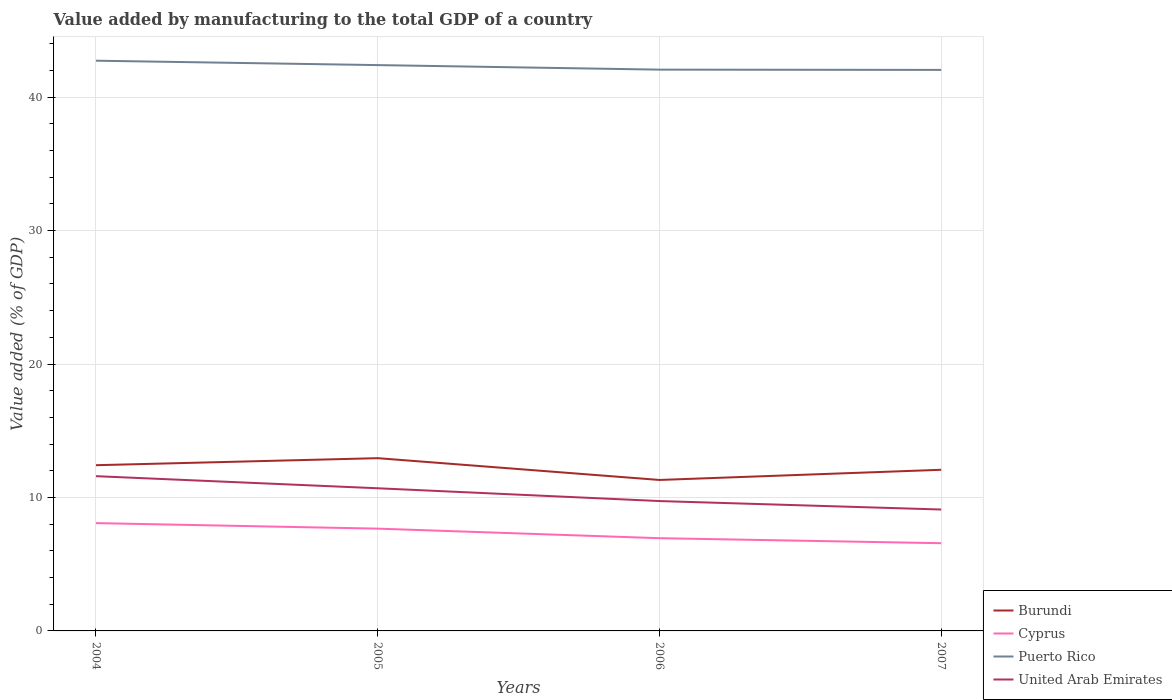Does the line corresponding to United Arab Emirates intersect with the line corresponding to Burundi?
Provide a short and direct response. No. Across all years, what is the maximum value added by manufacturing to the total GDP in Burundi?
Make the answer very short. 11.31. In which year was the value added by manufacturing to the total GDP in United Arab Emirates maximum?
Give a very brief answer. 2007. What is the total value added by manufacturing to the total GDP in United Arab Emirates in the graph?
Provide a succinct answer. 0.63. What is the difference between the highest and the second highest value added by manufacturing to the total GDP in Burundi?
Your response must be concise. 1.63. What is the difference between the highest and the lowest value added by manufacturing to the total GDP in Puerto Rico?
Keep it short and to the point. 2. How many lines are there?
Your response must be concise. 4. How many years are there in the graph?
Provide a succinct answer. 4. Are the values on the major ticks of Y-axis written in scientific E-notation?
Keep it short and to the point. No. Does the graph contain any zero values?
Offer a terse response. No. What is the title of the graph?
Give a very brief answer. Value added by manufacturing to the total GDP of a country. What is the label or title of the X-axis?
Your response must be concise. Years. What is the label or title of the Y-axis?
Offer a terse response. Value added (% of GDP). What is the Value added (% of GDP) in Burundi in 2004?
Your answer should be compact. 12.42. What is the Value added (% of GDP) in Cyprus in 2004?
Your answer should be very brief. 8.08. What is the Value added (% of GDP) in Puerto Rico in 2004?
Provide a short and direct response. 42.73. What is the Value added (% of GDP) of United Arab Emirates in 2004?
Your answer should be compact. 11.6. What is the Value added (% of GDP) of Burundi in 2005?
Keep it short and to the point. 12.95. What is the Value added (% of GDP) in Cyprus in 2005?
Your response must be concise. 7.66. What is the Value added (% of GDP) in Puerto Rico in 2005?
Keep it short and to the point. 42.4. What is the Value added (% of GDP) of United Arab Emirates in 2005?
Ensure brevity in your answer.  10.69. What is the Value added (% of GDP) in Burundi in 2006?
Your answer should be very brief. 11.31. What is the Value added (% of GDP) of Cyprus in 2006?
Provide a short and direct response. 6.95. What is the Value added (% of GDP) in Puerto Rico in 2006?
Your answer should be very brief. 42.06. What is the Value added (% of GDP) of United Arab Emirates in 2006?
Offer a terse response. 9.73. What is the Value added (% of GDP) in Burundi in 2007?
Provide a succinct answer. 12.07. What is the Value added (% of GDP) of Cyprus in 2007?
Your answer should be compact. 6.57. What is the Value added (% of GDP) in Puerto Rico in 2007?
Make the answer very short. 42.04. What is the Value added (% of GDP) of United Arab Emirates in 2007?
Provide a succinct answer. 9.1. Across all years, what is the maximum Value added (% of GDP) in Burundi?
Your response must be concise. 12.95. Across all years, what is the maximum Value added (% of GDP) in Cyprus?
Offer a terse response. 8.08. Across all years, what is the maximum Value added (% of GDP) in Puerto Rico?
Offer a very short reply. 42.73. Across all years, what is the maximum Value added (% of GDP) of United Arab Emirates?
Make the answer very short. 11.6. Across all years, what is the minimum Value added (% of GDP) of Burundi?
Provide a succinct answer. 11.31. Across all years, what is the minimum Value added (% of GDP) of Cyprus?
Ensure brevity in your answer.  6.57. Across all years, what is the minimum Value added (% of GDP) in Puerto Rico?
Your answer should be very brief. 42.04. Across all years, what is the minimum Value added (% of GDP) of United Arab Emirates?
Provide a short and direct response. 9.1. What is the total Value added (% of GDP) in Burundi in the graph?
Give a very brief answer. 48.75. What is the total Value added (% of GDP) of Cyprus in the graph?
Your answer should be compact. 29.27. What is the total Value added (% of GDP) in Puerto Rico in the graph?
Keep it short and to the point. 169.23. What is the total Value added (% of GDP) in United Arab Emirates in the graph?
Your answer should be very brief. 41.12. What is the difference between the Value added (% of GDP) of Burundi in 2004 and that in 2005?
Offer a very short reply. -0.53. What is the difference between the Value added (% of GDP) of Cyprus in 2004 and that in 2005?
Make the answer very short. 0.42. What is the difference between the Value added (% of GDP) in Puerto Rico in 2004 and that in 2005?
Provide a succinct answer. 0.33. What is the difference between the Value added (% of GDP) of United Arab Emirates in 2004 and that in 2005?
Make the answer very short. 0.91. What is the difference between the Value added (% of GDP) in Burundi in 2004 and that in 2006?
Your response must be concise. 1.11. What is the difference between the Value added (% of GDP) of Cyprus in 2004 and that in 2006?
Your answer should be very brief. 1.13. What is the difference between the Value added (% of GDP) of Puerto Rico in 2004 and that in 2006?
Offer a very short reply. 0.67. What is the difference between the Value added (% of GDP) of United Arab Emirates in 2004 and that in 2006?
Your response must be concise. 1.86. What is the difference between the Value added (% of GDP) in Burundi in 2004 and that in 2007?
Offer a very short reply. 0.34. What is the difference between the Value added (% of GDP) of Cyprus in 2004 and that in 2007?
Offer a very short reply. 1.51. What is the difference between the Value added (% of GDP) of Puerto Rico in 2004 and that in 2007?
Offer a terse response. 0.69. What is the difference between the Value added (% of GDP) in United Arab Emirates in 2004 and that in 2007?
Keep it short and to the point. 2.5. What is the difference between the Value added (% of GDP) in Burundi in 2005 and that in 2006?
Offer a terse response. 1.63. What is the difference between the Value added (% of GDP) in Cyprus in 2005 and that in 2006?
Give a very brief answer. 0.71. What is the difference between the Value added (% of GDP) in Puerto Rico in 2005 and that in 2006?
Your answer should be very brief. 0.34. What is the difference between the Value added (% of GDP) in United Arab Emirates in 2005 and that in 2006?
Offer a terse response. 0.96. What is the difference between the Value added (% of GDP) of Burundi in 2005 and that in 2007?
Keep it short and to the point. 0.87. What is the difference between the Value added (% of GDP) in Cyprus in 2005 and that in 2007?
Provide a short and direct response. 1.09. What is the difference between the Value added (% of GDP) in Puerto Rico in 2005 and that in 2007?
Offer a very short reply. 0.36. What is the difference between the Value added (% of GDP) in United Arab Emirates in 2005 and that in 2007?
Your response must be concise. 1.59. What is the difference between the Value added (% of GDP) in Burundi in 2006 and that in 2007?
Keep it short and to the point. -0.76. What is the difference between the Value added (% of GDP) of Cyprus in 2006 and that in 2007?
Offer a terse response. 0.38. What is the difference between the Value added (% of GDP) in Puerto Rico in 2006 and that in 2007?
Keep it short and to the point. 0.02. What is the difference between the Value added (% of GDP) of United Arab Emirates in 2006 and that in 2007?
Your answer should be very brief. 0.63. What is the difference between the Value added (% of GDP) of Burundi in 2004 and the Value added (% of GDP) of Cyprus in 2005?
Give a very brief answer. 4.75. What is the difference between the Value added (% of GDP) in Burundi in 2004 and the Value added (% of GDP) in Puerto Rico in 2005?
Provide a short and direct response. -29.98. What is the difference between the Value added (% of GDP) in Burundi in 2004 and the Value added (% of GDP) in United Arab Emirates in 2005?
Your answer should be very brief. 1.73. What is the difference between the Value added (% of GDP) of Cyprus in 2004 and the Value added (% of GDP) of Puerto Rico in 2005?
Provide a short and direct response. -34.32. What is the difference between the Value added (% of GDP) in Cyprus in 2004 and the Value added (% of GDP) in United Arab Emirates in 2005?
Give a very brief answer. -2.61. What is the difference between the Value added (% of GDP) in Puerto Rico in 2004 and the Value added (% of GDP) in United Arab Emirates in 2005?
Keep it short and to the point. 32.04. What is the difference between the Value added (% of GDP) of Burundi in 2004 and the Value added (% of GDP) of Cyprus in 2006?
Provide a short and direct response. 5.47. What is the difference between the Value added (% of GDP) in Burundi in 2004 and the Value added (% of GDP) in Puerto Rico in 2006?
Your answer should be compact. -29.64. What is the difference between the Value added (% of GDP) of Burundi in 2004 and the Value added (% of GDP) of United Arab Emirates in 2006?
Offer a terse response. 2.69. What is the difference between the Value added (% of GDP) of Cyprus in 2004 and the Value added (% of GDP) of Puerto Rico in 2006?
Your answer should be compact. -33.98. What is the difference between the Value added (% of GDP) of Cyprus in 2004 and the Value added (% of GDP) of United Arab Emirates in 2006?
Provide a succinct answer. -1.65. What is the difference between the Value added (% of GDP) in Puerto Rico in 2004 and the Value added (% of GDP) in United Arab Emirates in 2006?
Make the answer very short. 33. What is the difference between the Value added (% of GDP) in Burundi in 2004 and the Value added (% of GDP) in Cyprus in 2007?
Offer a very short reply. 5.84. What is the difference between the Value added (% of GDP) of Burundi in 2004 and the Value added (% of GDP) of Puerto Rico in 2007?
Offer a very short reply. -29.62. What is the difference between the Value added (% of GDP) in Burundi in 2004 and the Value added (% of GDP) in United Arab Emirates in 2007?
Your answer should be compact. 3.32. What is the difference between the Value added (% of GDP) in Cyprus in 2004 and the Value added (% of GDP) in Puerto Rico in 2007?
Give a very brief answer. -33.96. What is the difference between the Value added (% of GDP) in Cyprus in 2004 and the Value added (% of GDP) in United Arab Emirates in 2007?
Your answer should be compact. -1.02. What is the difference between the Value added (% of GDP) of Puerto Rico in 2004 and the Value added (% of GDP) of United Arab Emirates in 2007?
Keep it short and to the point. 33.63. What is the difference between the Value added (% of GDP) in Burundi in 2005 and the Value added (% of GDP) in Cyprus in 2006?
Your answer should be very brief. 6. What is the difference between the Value added (% of GDP) in Burundi in 2005 and the Value added (% of GDP) in Puerto Rico in 2006?
Your answer should be very brief. -29.12. What is the difference between the Value added (% of GDP) in Burundi in 2005 and the Value added (% of GDP) in United Arab Emirates in 2006?
Offer a terse response. 3.21. What is the difference between the Value added (% of GDP) of Cyprus in 2005 and the Value added (% of GDP) of Puerto Rico in 2006?
Your response must be concise. -34.4. What is the difference between the Value added (% of GDP) of Cyprus in 2005 and the Value added (% of GDP) of United Arab Emirates in 2006?
Ensure brevity in your answer.  -2.07. What is the difference between the Value added (% of GDP) in Puerto Rico in 2005 and the Value added (% of GDP) in United Arab Emirates in 2006?
Give a very brief answer. 32.67. What is the difference between the Value added (% of GDP) of Burundi in 2005 and the Value added (% of GDP) of Cyprus in 2007?
Your response must be concise. 6.37. What is the difference between the Value added (% of GDP) in Burundi in 2005 and the Value added (% of GDP) in Puerto Rico in 2007?
Your answer should be compact. -29.1. What is the difference between the Value added (% of GDP) of Burundi in 2005 and the Value added (% of GDP) of United Arab Emirates in 2007?
Offer a terse response. 3.85. What is the difference between the Value added (% of GDP) in Cyprus in 2005 and the Value added (% of GDP) in Puerto Rico in 2007?
Ensure brevity in your answer.  -34.38. What is the difference between the Value added (% of GDP) in Cyprus in 2005 and the Value added (% of GDP) in United Arab Emirates in 2007?
Keep it short and to the point. -1.43. What is the difference between the Value added (% of GDP) in Puerto Rico in 2005 and the Value added (% of GDP) in United Arab Emirates in 2007?
Your response must be concise. 33.3. What is the difference between the Value added (% of GDP) of Burundi in 2006 and the Value added (% of GDP) of Cyprus in 2007?
Give a very brief answer. 4.74. What is the difference between the Value added (% of GDP) in Burundi in 2006 and the Value added (% of GDP) in Puerto Rico in 2007?
Offer a terse response. -30.73. What is the difference between the Value added (% of GDP) of Burundi in 2006 and the Value added (% of GDP) of United Arab Emirates in 2007?
Offer a terse response. 2.21. What is the difference between the Value added (% of GDP) in Cyprus in 2006 and the Value added (% of GDP) in Puerto Rico in 2007?
Provide a short and direct response. -35.09. What is the difference between the Value added (% of GDP) in Cyprus in 2006 and the Value added (% of GDP) in United Arab Emirates in 2007?
Ensure brevity in your answer.  -2.15. What is the difference between the Value added (% of GDP) in Puerto Rico in 2006 and the Value added (% of GDP) in United Arab Emirates in 2007?
Offer a terse response. 32.96. What is the average Value added (% of GDP) of Burundi per year?
Give a very brief answer. 12.19. What is the average Value added (% of GDP) of Cyprus per year?
Ensure brevity in your answer.  7.32. What is the average Value added (% of GDP) of Puerto Rico per year?
Your response must be concise. 42.31. What is the average Value added (% of GDP) of United Arab Emirates per year?
Provide a short and direct response. 10.28. In the year 2004, what is the difference between the Value added (% of GDP) in Burundi and Value added (% of GDP) in Cyprus?
Provide a short and direct response. 4.34. In the year 2004, what is the difference between the Value added (% of GDP) of Burundi and Value added (% of GDP) of Puerto Rico?
Give a very brief answer. -30.31. In the year 2004, what is the difference between the Value added (% of GDP) of Burundi and Value added (% of GDP) of United Arab Emirates?
Your answer should be compact. 0.82. In the year 2004, what is the difference between the Value added (% of GDP) of Cyprus and Value added (% of GDP) of Puerto Rico?
Provide a short and direct response. -34.65. In the year 2004, what is the difference between the Value added (% of GDP) in Cyprus and Value added (% of GDP) in United Arab Emirates?
Ensure brevity in your answer.  -3.52. In the year 2004, what is the difference between the Value added (% of GDP) of Puerto Rico and Value added (% of GDP) of United Arab Emirates?
Give a very brief answer. 31.13. In the year 2005, what is the difference between the Value added (% of GDP) of Burundi and Value added (% of GDP) of Cyprus?
Offer a very short reply. 5.28. In the year 2005, what is the difference between the Value added (% of GDP) of Burundi and Value added (% of GDP) of Puerto Rico?
Offer a very short reply. -29.46. In the year 2005, what is the difference between the Value added (% of GDP) of Burundi and Value added (% of GDP) of United Arab Emirates?
Ensure brevity in your answer.  2.26. In the year 2005, what is the difference between the Value added (% of GDP) of Cyprus and Value added (% of GDP) of Puerto Rico?
Make the answer very short. -34.74. In the year 2005, what is the difference between the Value added (% of GDP) of Cyprus and Value added (% of GDP) of United Arab Emirates?
Offer a very short reply. -3.03. In the year 2005, what is the difference between the Value added (% of GDP) of Puerto Rico and Value added (% of GDP) of United Arab Emirates?
Offer a very short reply. 31.71. In the year 2006, what is the difference between the Value added (% of GDP) in Burundi and Value added (% of GDP) in Cyprus?
Ensure brevity in your answer.  4.36. In the year 2006, what is the difference between the Value added (% of GDP) in Burundi and Value added (% of GDP) in Puerto Rico?
Ensure brevity in your answer.  -30.75. In the year 2006, what is the difference between the Value added (% of GDP) in Burundi and Value added (% of GDP) in United Arab Emirates?
Make the answer very short. 1.58. In the year 2006, what is the difference between the Value added (% of GDP) in Cyprus and Value added (% of GDP) in Puerto Rico?
Give a very brief answer. -35.11. In the year 2006, what is the difference between the Value added (% of GDP) of Cyprus and Value added (% of GDP) of United Arab Emirates?
Ensure brevity in your answer.  -2.78. In the year 2006, what is the difference between the Value added (% of GDP) in Puerto Rico and Value added (% of GDP) in United Arab Emirates?
Offer a terse response. 32.33. In the year 2007, what is the difference between the Value added (% of GDP) of Burundi and Value added (% of GDP) of Cyprus?
Your answer should be compact. 5.5. In the year 2007, what is the difference between the Value added (% of GDP) in Burundi and Value added (% of GDP) in Puerto Rico?
Your answer should be very brief. -29.97. In the year 2007, what is the difference between the Value added (% of GDP) in Burundi and Value added (% of GDP) in United Arab Emirates?
Offer a terse response. 2.98. In the year 2007, what is the difference between the Value added (% of GDP) in Cyprus and Value added (% of GDP) in Puerto Rico?
Provide a succinct answer. -35.47. In the year 2007, what is the difference between the Value added (% of GDP) of Cyprus and Value added (% of GDP) of United Arab Emirates?
Your response must be concise. -2.52. In the year 2007, what is the difference between the Value added (% of GDP) of Puerto Rico and Value added (% of GDP) of United Arab Emirates?
Make the answer very short. 32.94. What is the ratio of the Value added (% of GDP) of Burundi in 2004 to that in 2005?
Give a very brief answer. 0.96. What is the ratio of the Value added (% of GDP) of Cyprus in 2004 to that in 2005?
Ensure brevity in your answer.  1.05. What is the ratio of the Value added (% of GDP) in Puerto Rico in 2004 to that in 2005?
Ensure brevity in your answer.  1.01. What is the ratio of the Value added (% of GDP) of United Arab Emirates in 2004 to that in 2005?
Keep it short and to the point. 1.08. What is the ratio of the Value added (% of GDP) in Burundi in 2004 to that in 2006?
Provide a short and direct response. 1.1. What is the ratio of the Value added (% of GDP) of Cyprus in 2004 to that in 2006?
Your answer should be compact. 1.16. What is the ratio of the Value added (% of GDP) of Puerto Rico in 2004 to that in 2006?
Provide a short and direct response. 1.02. What is the ratio of the Value added (% of GDP) in United Arab Emirates in 2004 to that in 2006?
Your answer should be very brief. 1.19. What is the ratio of the Value added (% of GDP) in Burundi in 2004 to that in 2007?
Your response must be concise. 1.03. What is the ratio of the Value added (% of GDP) of Cyprus in 2004 to that in 2007?
Keep it short and to the point. 1.23. What is the ratio of the Value added (% of GDP) of Puerto Rico in 2004 to that in 2007?
Keep it short and to the point. 1.02. What is the ratio of the Value added (% of GDP) of United Arab Emirates in 2004 to that in 2007?
Give a very brief answer. 1.27. What is the ratio of the Value added (% of GDP) in Burundi in 2005 to that in 2006?
Offer a very short reply. 1.14. What is the ratio of the Value added (% of GDP) of Cyprus in 2005 to that in 2006?
Your answer should be very brief. 1.1. What is the ratio of the Value added (% of GDP) in Puerto Rico in 2005 to that in 2006?
Your answer should be very brief. 1.01. What is the ratio of the Value added (% of GDP) in United Arab Emirates in 2005 to that in 2006?
Provide a short and direct response. 1.1. What is the ratio of the Value added (% of GDP) of Burundi in 2005 to that in 2007?
Ensure brevity in your answer.  1.07. What is the ratio of the Value added (% of GDP) in Cyprus in 2005 to that in 2007?
Offer a terse response. 1.17. What is the ratio of the Value added (% of GDP) of Puerto Rico in 2005 to that in 2007?
Your answer should be very brief. 1.01. What is the ratio of the Value added (% of GDP) in United Arab Emirates in 2005 to that in 2007?
Provide a succinct answer. 1.17. What is the ratio of the Value added (% of GDP) of Burundi in 2006 to that in 2007?
Offer a very short reply. 0.94. What is the ratio of the Value added (% of GDP) in Cyprus in 2006 to that in 2007?
Make the answer very short. 1.06. What is the ratio of the Value added (% of GDP) in United Arab Emirates in 2006 to that in 2007?
Your response must be concise. 1.07. What is the difference between the highest and the second highest Value added (% of GDP) in Burundi?
Provide a succinct answer. 0.53. What is the difference between the highest and the second highest Value added (% of GDP) in Cyprus?
Your answer should be very brief. 0.42. What is the difference between the highest and the second highest Value added (% of GDP) of Puerto Rico?
Give a very brief answer. 0.33. What is the difference between the highest and the second highest Value added (% of GDP) in United Arab Emirates?
Keep it short and to the point. 0.91. What is the difference between the highest and the lowest Value added (% of GDP) of Burundi?
Your answer should be very brief. 1.63. What is the difference between the highest and the lowest Value added (% of GDP) of Cyprus?
Offer a terse response. 1.51. What is the difference between the highest and the lowest Value added (% of GDP) in Puerto Rico?
Your answer should be very brief. 0.69. What is the difference between the highest and the lowest Value added (% of GDP) in United Arab Emirates?
Provide a succinct answer. 2.5. 